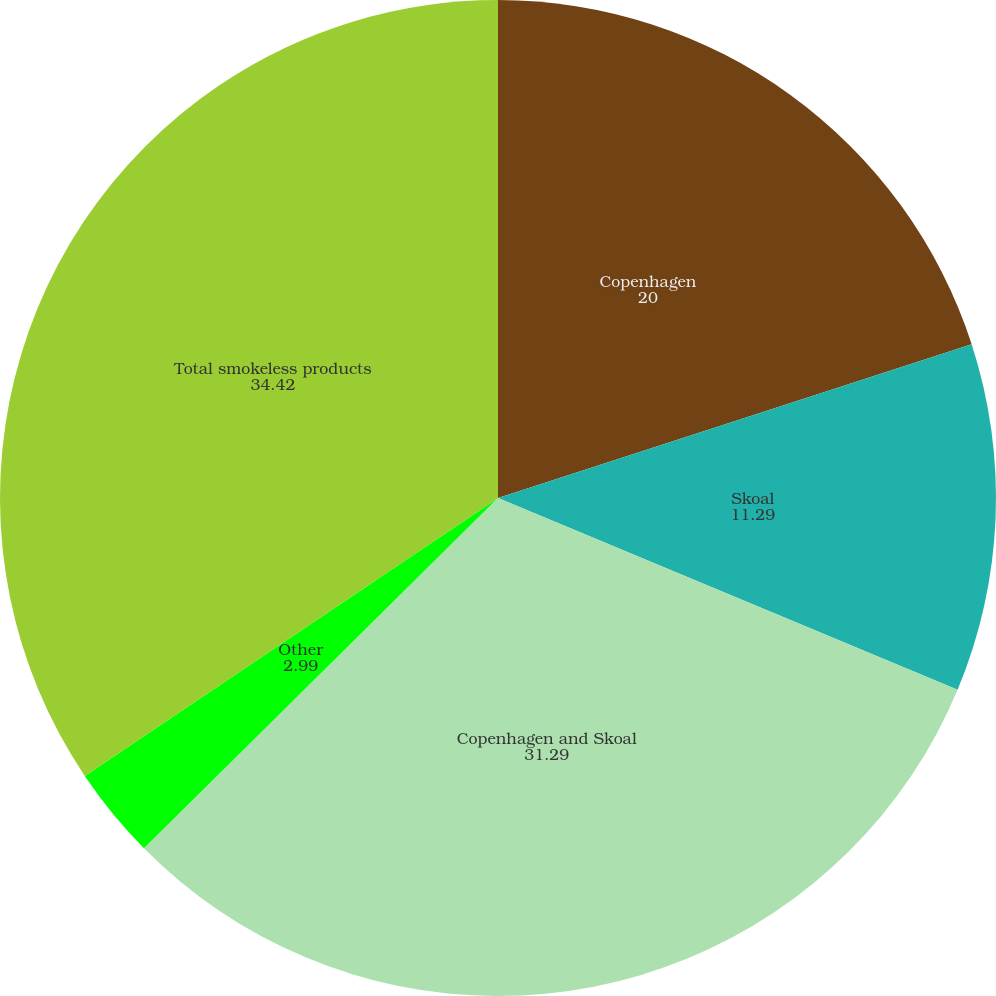Convert chart. <chart><loc_0><loc_0><loc_500><loc_500><pie_chart><fcel>Copenhagen<fcel>Skoal<fcel>Copenhagen and Skoal<fcel>Other<fcel>Total smokeless products<nl><fcel>20.0%<fcel>11.29%<fcel>31.29%<fcel>2.99%<fcel>34.42%<nl></chart> 